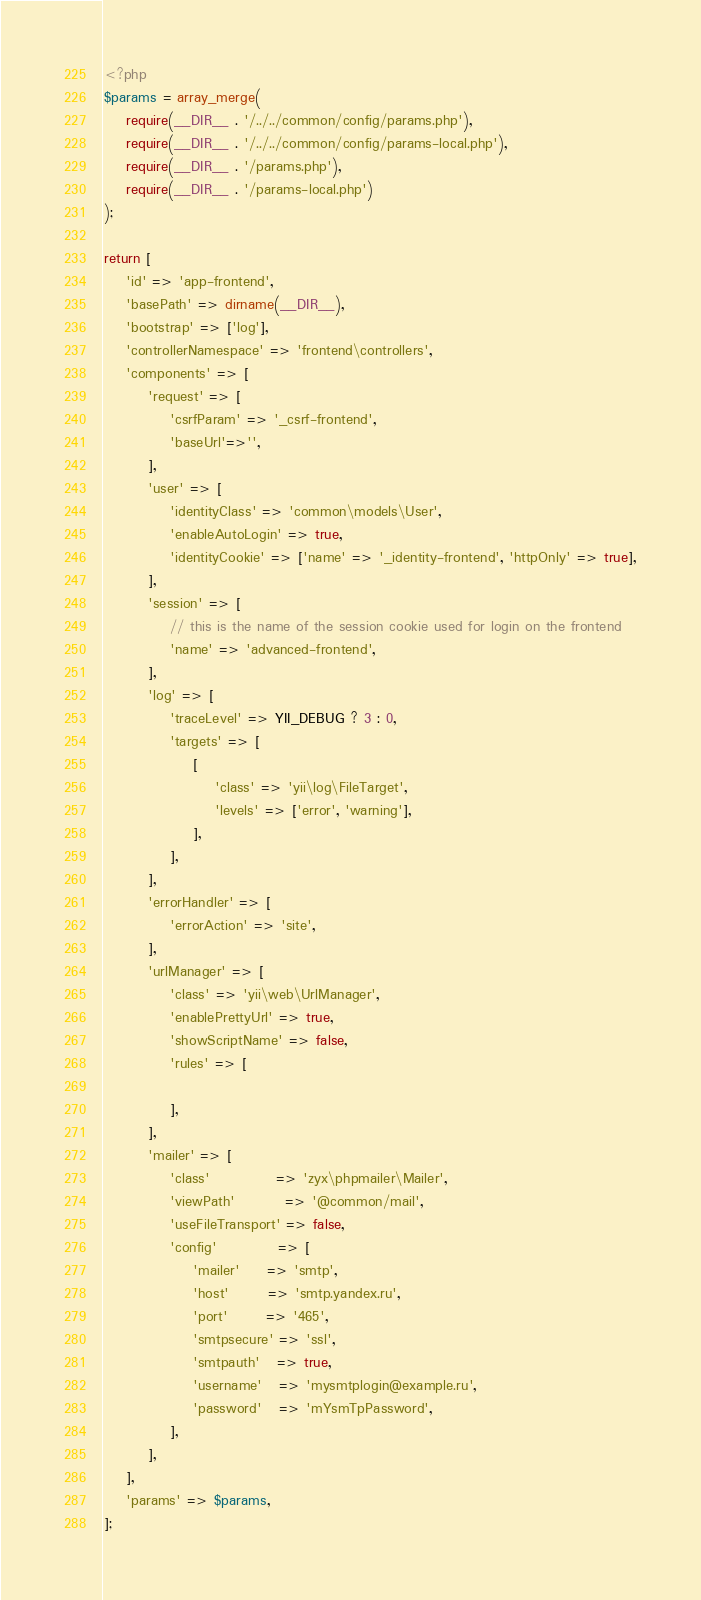Convert code to text. <code><loc_0><loc_0><loc_500><loc_500><_PHP_><?php
$params = array_merge(
    require(__DIR__ . '/../../common/config/params.php'),
    require(__DIR__ . '/../../common/config/params-local.php'),
    require(__DIR__ . '/params.php'),
    require(__DIR__ . '/params-local.php')
);

return [
    'id' => 'app-frontend',
    'basePath' => dirname(__DIR__),
    'bootstrap' => ['log'],
    'controllerNamespace' => 'frontend\controllers',
    'components' => [
        'request' => [
            'csrfParam' => '_csrf-frontend',
            'baseUrl'=>'',
        ],
        'user' => [
            'identityClass' => 'common\models\User',
            'enableAutoLogin' => true,
            'identityCookie' => ['name' => '_identity-frontend', 'httpOnly' => true],
        ],
        'session' => [
            // this is the name of the session cookie used for login on the frontend
            'name' => 'advanced-frontend',
        ],
        'log' => [
            'traceLevel' => YII_DEBUG ? 3 : 0,
            'targets' => [
                [
                    'class' => 'yii\log\FileTarget',
                    'levels' => ['error', 'warning'],
                ],
            ],
        ],
        'errorHandler' => [
            'errorAction' => 'site',
        ],
        'urlManager' => [
            'class' => 'yii\web\UrlManager',
            'enablePrettyUrl' => true,
            'showScriptName' => false,
            'rules' => [

            ],
        ],
        'mailer' => [
            'class'            => 'zyx\phpmailer\Mailer',
            'viewPath'         => '@common/mail',
            'useFileTransport' => false,
            'config'           => [
                'mailer'     => 'smtp',
                'host'       => 'smtp.yandex.ru',
                'port'       => '465',
                'smtpsecure' => 'ssl',
                'smtpauth'   => true,
                'username'   => 'mysmtplogin@example.ru',
                'password'   => 'mYsmTpPassword',
            ],
        ],
    ],
    'params' => $params,
];
</code> 